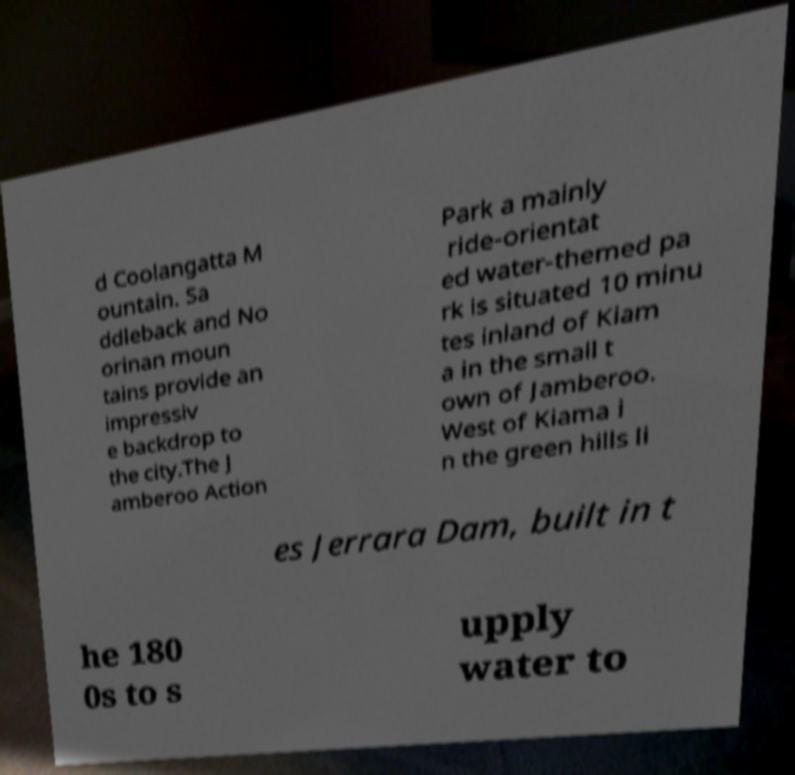Please read and relay the text visible in this image. What does it say? d Coolangatta M ountain. Sa ddleback and No orinan moun tains provide an impressiv e backdrop to the city.The J amberoo Action Park a mainly ride-orientat ed water-themed pa rk is situated 10 minu tes inland of Kiam a in the small t own of Jamberoo. West of Kiama i n the green hills li es Jerrara Dam, built in t he 180 0s to s upply water to 